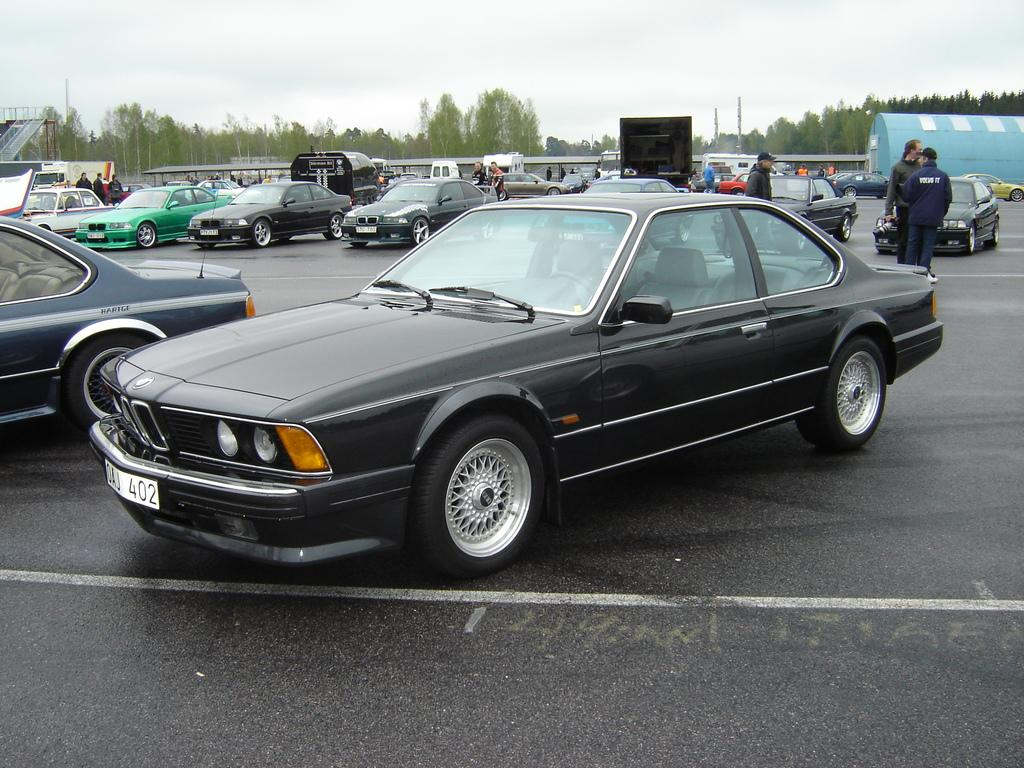What can be seen on the road in the image? Vehicles are on the road in the image. Are there any people visible in the scene? Yes, there are people visible in the image. What is located far in the distance in the image? Trees are far in the distance in the image. What type of structures are present in the scene? Poles are present in the scene, as well as an open-shed and a blue shed. What type of playground equipment is visible in the image? A slide is visible in the image. How would you describe the sky in the image? The sky is cloudy in the image. Where is the rake being used in the image? There is no rake present in the image. What type of flowers are in the vase on the table in the image? There is no vase or flowers present in the image. 